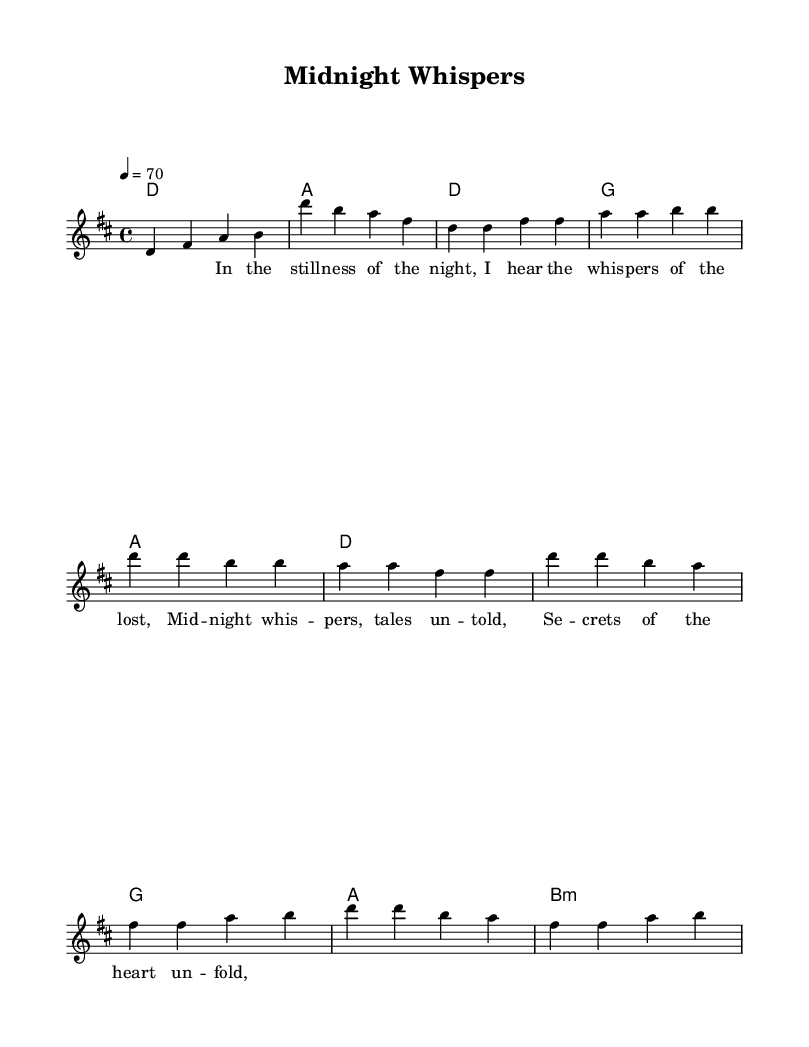What is the key signature of this music? The key signature is D major, which has two sharps: F# and C#.
Answer: D major What is the time signature of this music? The time signature is 4/4, meaning there are four beats in each measure.
Answer: 4/4 What is the tempo marking for this piece? The tempo is marked at 70 beats per minute, indicated by the numeral 4 = 70.
Answer: 70 How many parts are in the score? The score contains three parts: chord names, melody, and lyrics.
Answer: Three What is the first lyric note of the first verse? The first lyric note is "In", which corresponds with a D note in the melody.
Answer: In What chord appears at the start of the chorus? The first chord in the chorus is D major, which is indicated at the beginning of the chorus section.
Answer: D In the context of the song, what theme is suggested by the lyrics? The lyrics suggest themes of mystery and introspection, as indicated by phrases like "whispers of the lost" and "tales untold."
Answer: Mystery 